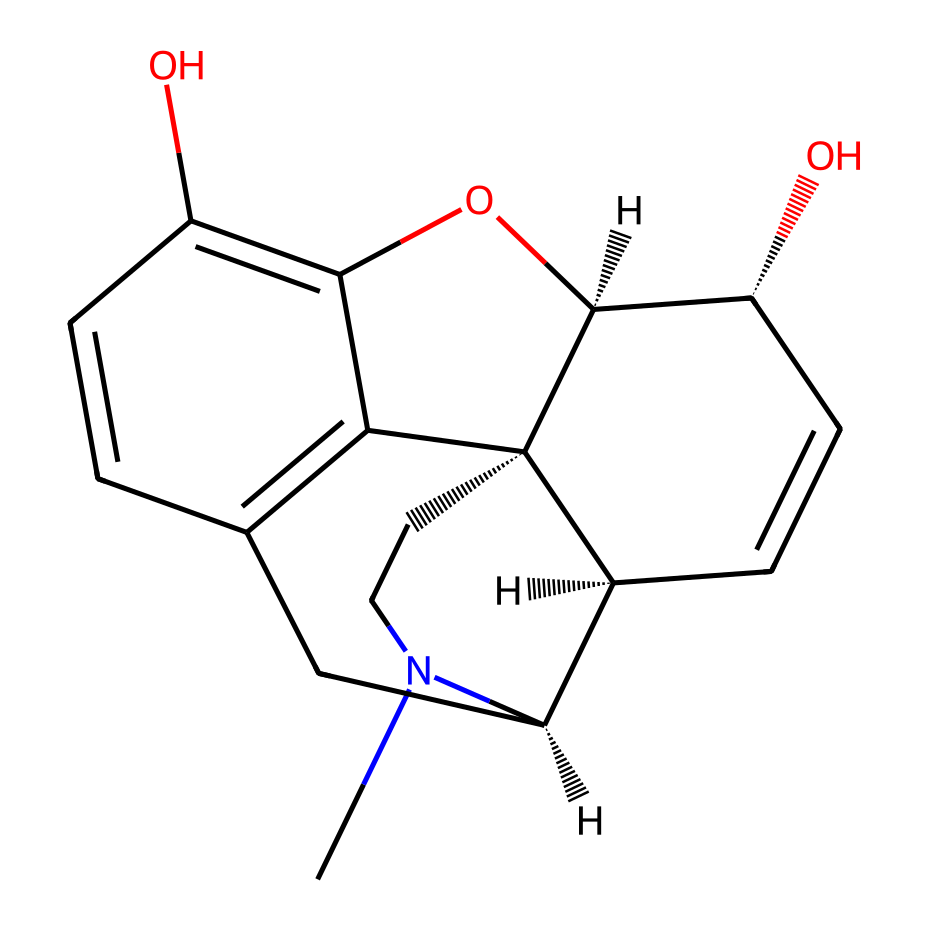What is the primary functional group present in morphine? The structure contains multiple hydroxyl groups (-OH), which are characteristic of phenolic compounds. The presence of these groups indicates that morphine has alcohol functional groups.
Answer: hydroxyl group How many carbon atoms are in the morphine structure? Upon counting the visible carbon atoms, we find that there are 17 carbon (C) atoms present in the structure.
Answer: 17 What type of alkaloid is morphine categorized as? Morphine is categorized as an opiate alkaloid due to its natural origin from the opium poppy and its role as a strong pain reliever.
Answer: opiate Which atom indicates potential basicity in the morphine structure? The nitrogen (N) atom present in the structure is typically associated with basicity in alkaloids. This nitrogen can accept protons making it a basic site in the molecule.
Answer: nitrogen What is the molecular formula of morphine derived from its structure? To derive the molecular formula, we count all atoms in the structure and find that it results in a formula of C17H19NO3, encompassing all constituent atoms.
Answer: C17H19NO3 How many rings are present in the morphine structure? By analyzing the cyclic nature of the structure, we can identify three fused rings in the morphine molecule when viewed in its 3D representation.
Answer: 3 Which characteristic of morphine contributes to its analgesic properties? The combination of the hydroxyl and nitrogen groups in the structure allows morphine to bind to opioid receptors, which contributes to its analgesic (pain-relieving) properties.
Answer: binding to opioid receptors 